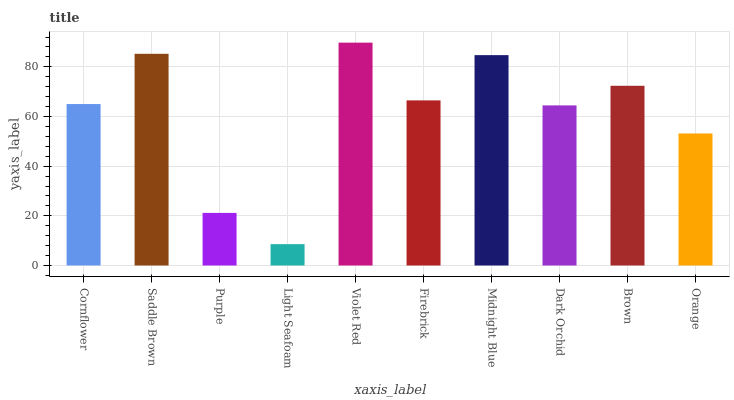Is Light Seafoam the minimum?
Answer yes or no. Yes. Is Violet Red the maximum?
Answer yes or no. Yes. Is Saddle Brown the minimum?
Answer yes or no. No. Is Saddle Brown the maximum?
Answer yes or no. No. Is Saddle Brown greater than Cornflower?
Answer yes or no. Yes. Is Cornflower less than Saddle Brown?
Answer yes or no. Yes. Is Cornflower greater than Saddle Brown?
Answer yes or no. No. Is Saddle Brown less than Cornflower?
Answer yes or no. No. Is Firebrick the high median?
Answer yes or no. Yes. Is Cornflower the low median?
Answer yes or no. Yes. Is Brown the high median?
Answer yes or no. No. Is Purple the low median?
Answer yes or no. No. 